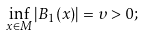<formula> <loc_0><loc_0><loc_500><loc_500>\inf _ { x \in M } | B _ { 1 } ( x ) | = \upsilon > 0 ;</formula> 